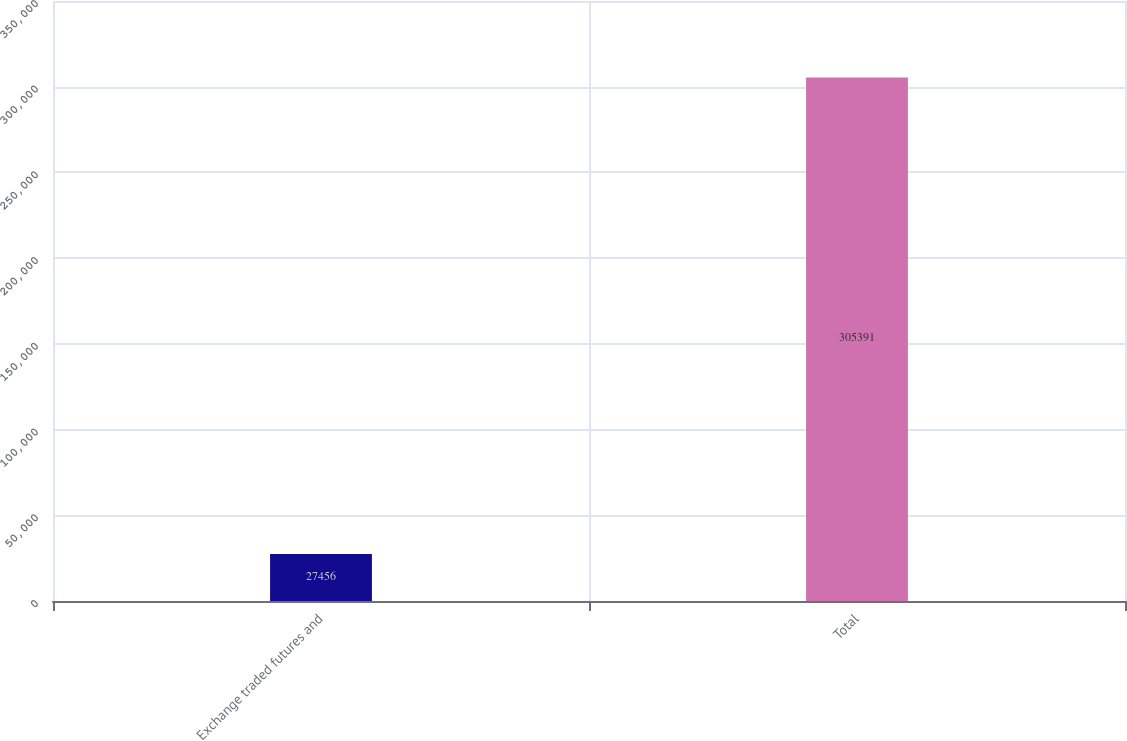Convert chart. <chart><loc_0><loc_0><loc_500><loc_500><bar_chart><fcel>Exchange traded futures and<fcel>Total<nl><fcel>27456<fcel>305391<nl></chart> 